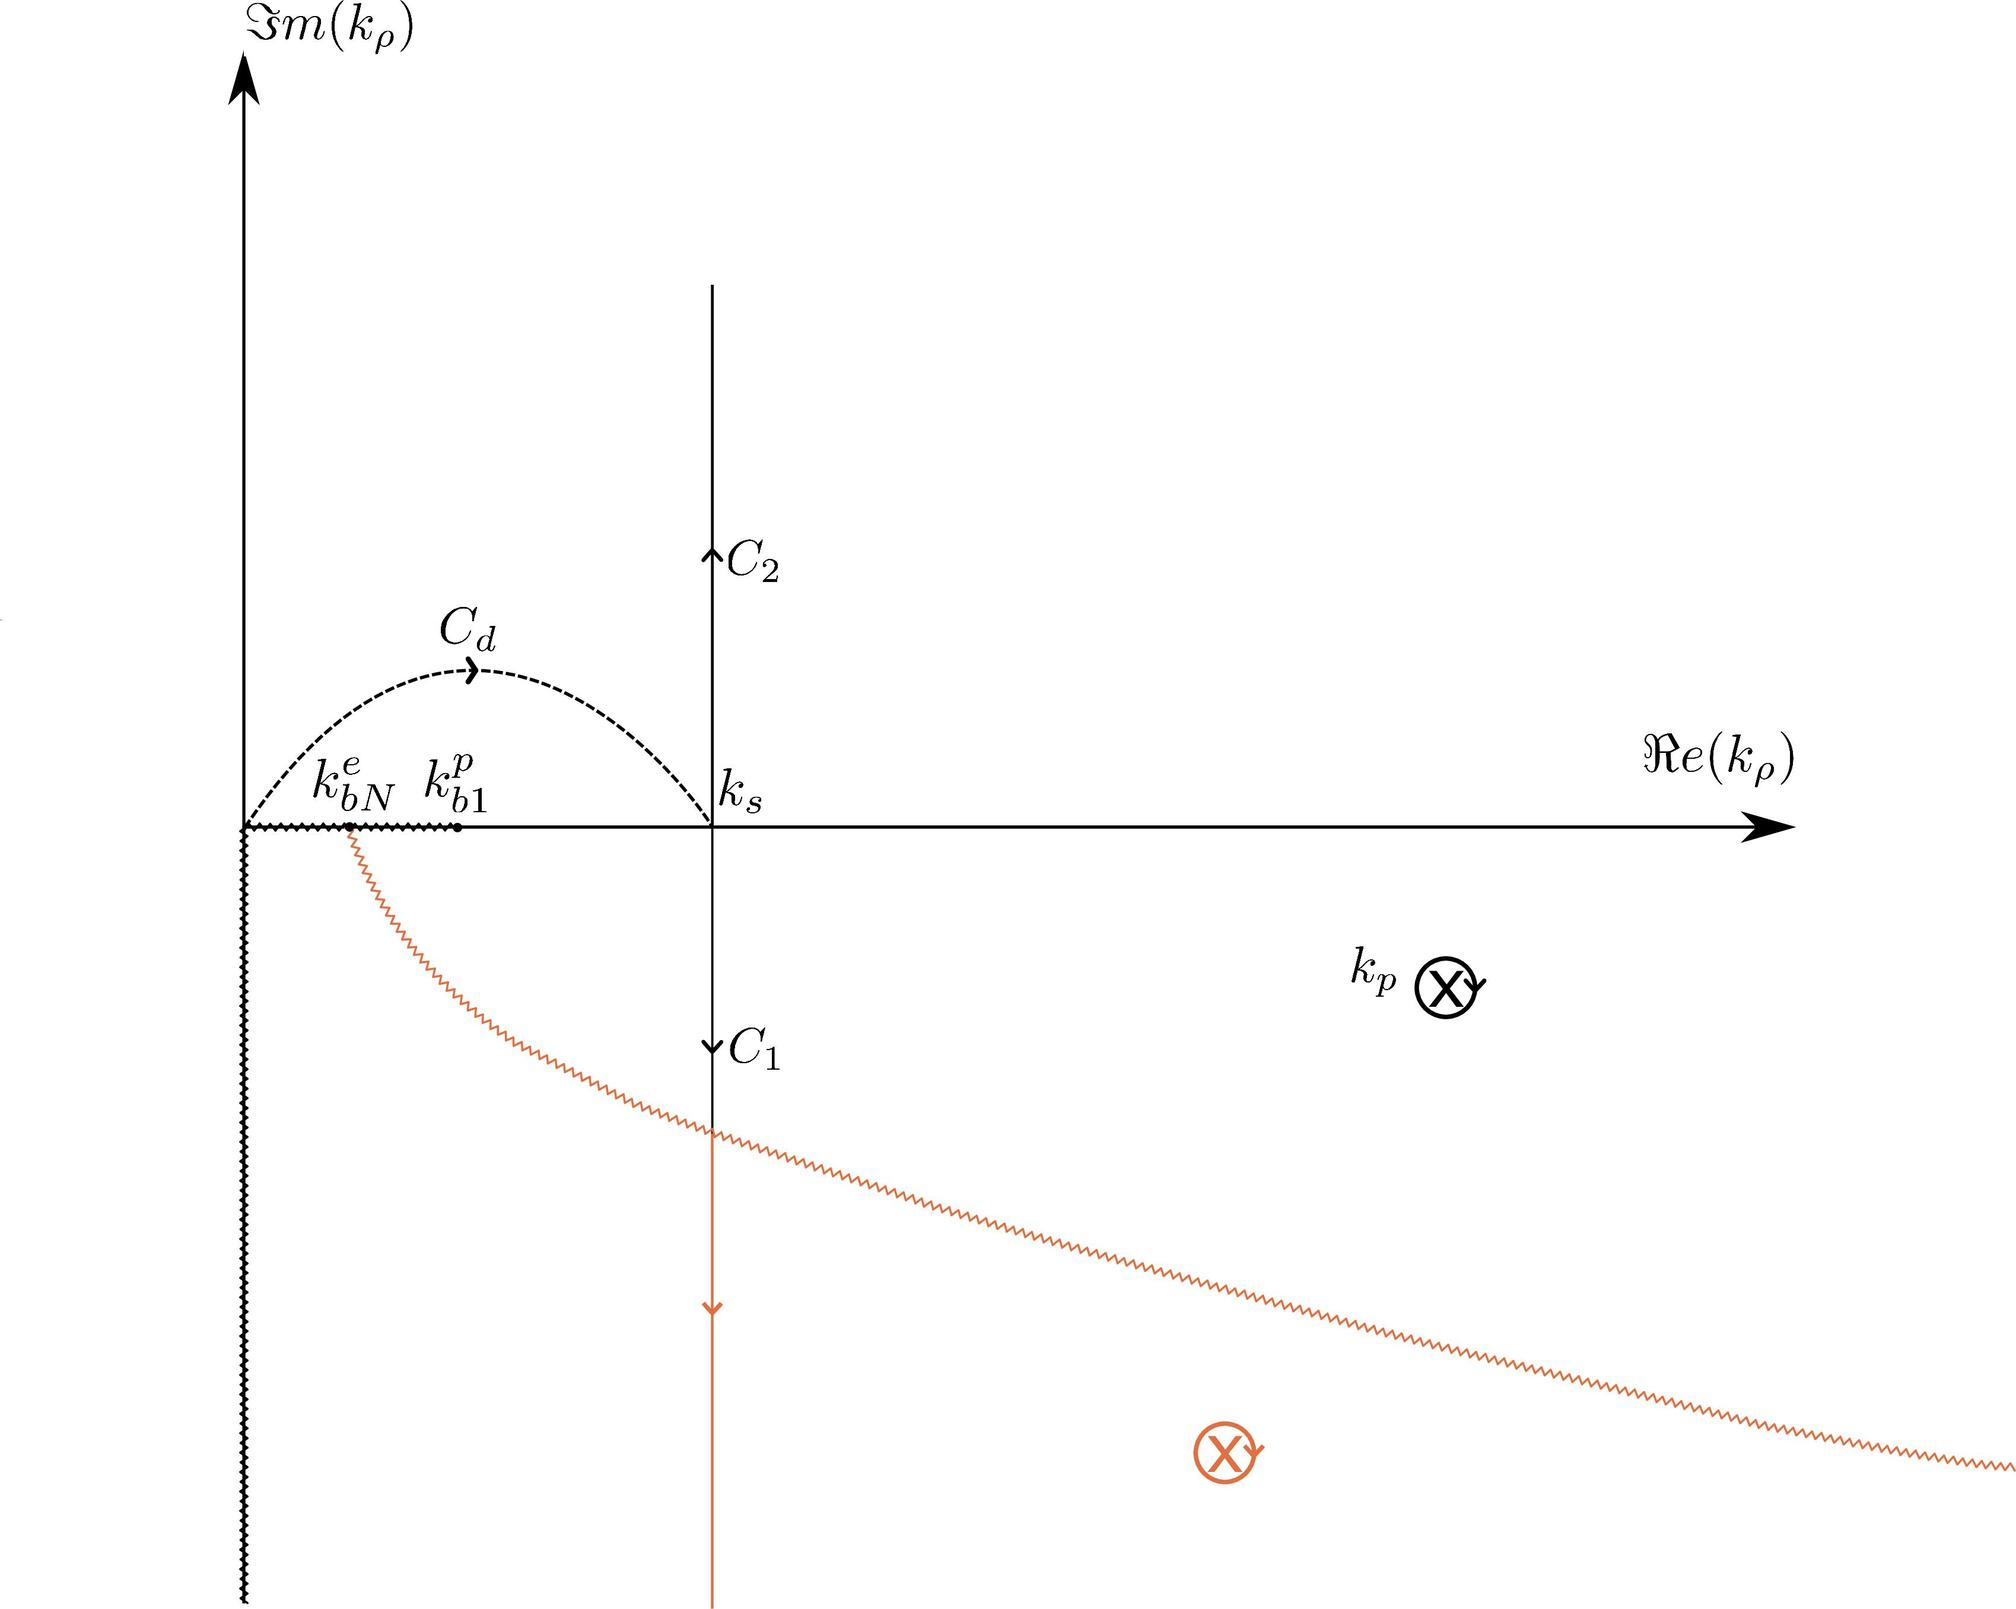What does the branch labeled \( C_d \) in the figure represent? A. A path showing the direction of decreasing real part of \( k_p \) B. A contour integral path in the complex \( k_p \) plane C. A branch cut for the complex function D. The trajectory of a particle in a field The branch labeled \( C_d \) appears to be a semicircular path in the complex plane, which is a common representation for a contour integral path. It is not a branch cut since those are typically represented by lines, not curves, and it's not related to physical trajectories or directions of decreasing values. Therefore, the correct answer is B. 